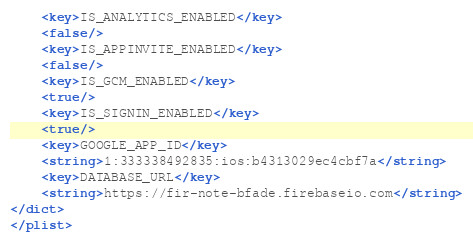Convert code to text. <code><loc_0><loc_0><loc_500><loc_500><_XML_>	<key>IS_ANALYTICS_ENABLED</key>
	<false/>
	<key>IS_APPINVITE_ENABLED</key>
	<false/>
	<key>IS_GCM_ENABLED</key>
	<true/>
	<key>IS_SIGNIN_ENABLED</key>
	<true/>
	<key>GOOGLE_APP_ID</key>
	<string>1:333338492835:ios:b4313029ec4cbf7a</string>
	<key>DATABASE_URL</key>
	<string>https://fir-note-bfade.firebaseio.com</string>
</dict>
</plist></code> 